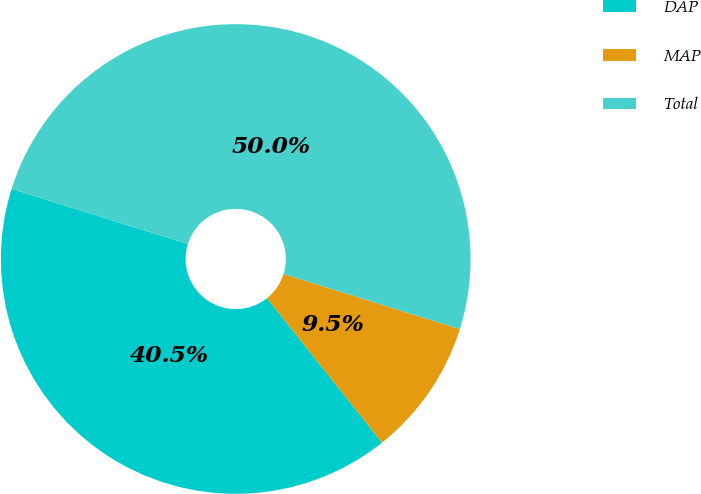Convert chart to OTSL. <chart><loc_0><loc_0><loc_500><loc_500><pie_chart><fcel>DAP<fcel>MAP<fcel>Total<nl><fcel>40.53%<fcel>9.47%<fcel>50.0%<nl></chart> 